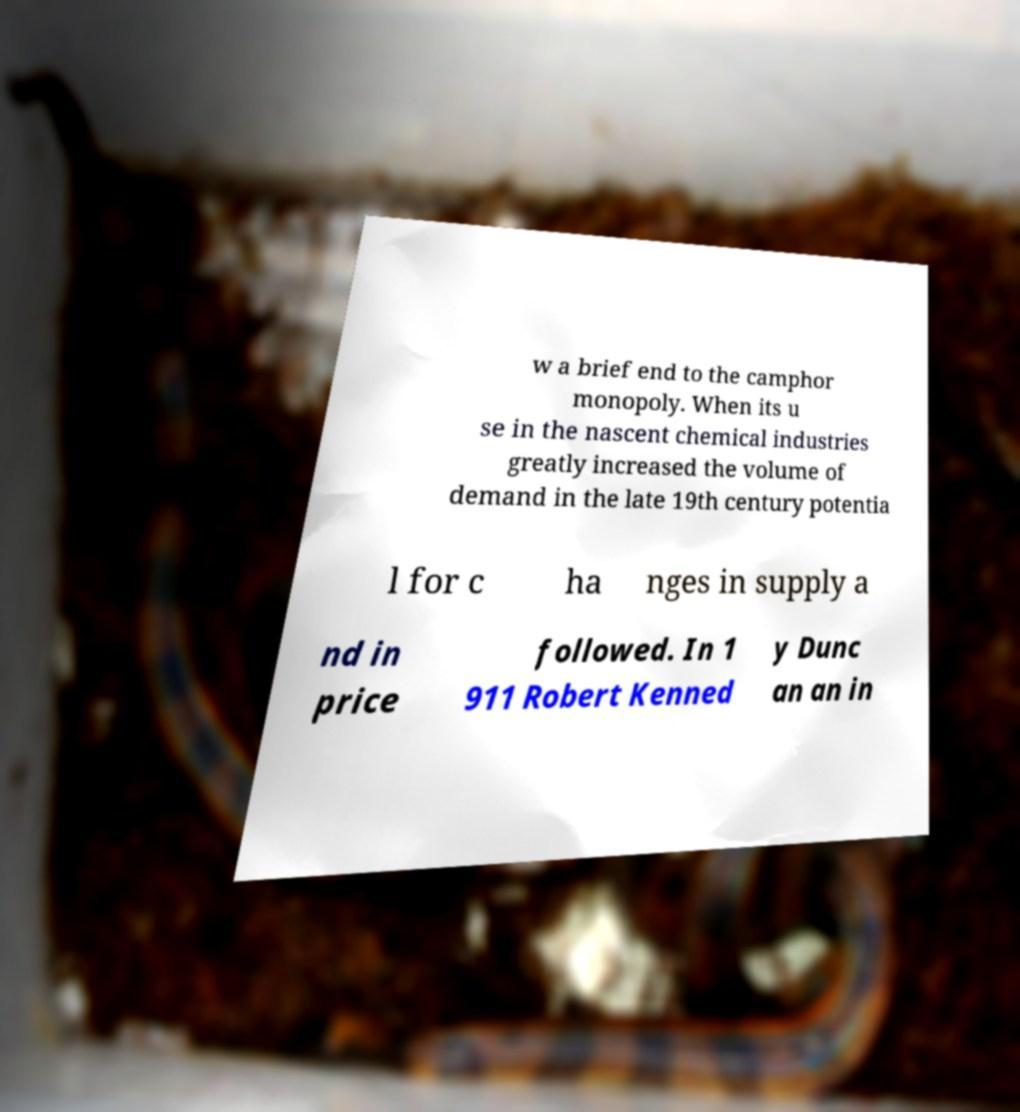Please identify and transcribe the text found in this image. w a brief end to the camphor monopoly. When its u se in the nascent chemical industries greatly increased the volume of demand in the late 19th century potentia l for c ha nges in supply a nd in price followed. In 1 911 Robert Kenned y Dunc an an in 